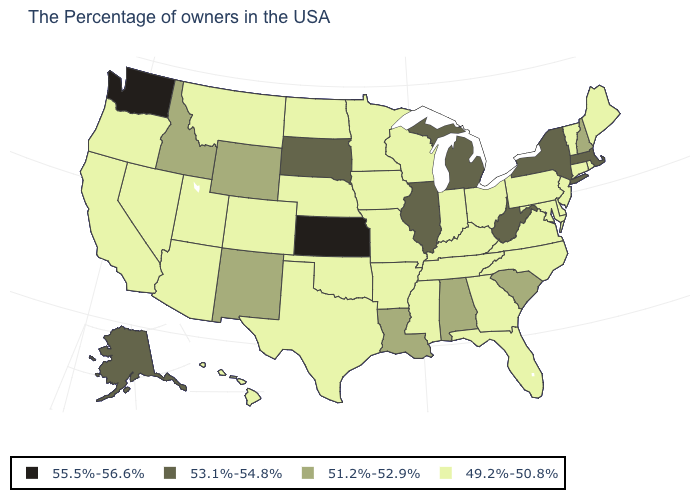Name the states that have a value in the range 55.5%-56.6%?
Give a very brief answer. Kansas, Washington. What is the value of New Hampshire?
Be succinct. 51.2%-52.9%. What is the value of Virginia?
Be succinct. 49.2%-50.8%. What is the value of Kansas?
Concise answer only. 55.5%-56.6%. Does Illinois have the lowest value in the MidWest?
Short answer required. No. Among the states that border Maine , which have the lowest value?
Give a very brief answer. New Hampshire. Is the legend a continuous bar?
Keep it brief. No. Does the map have missing data?
Answer briefly. No. What is the lowest value in the USA?
Be succinct. 49.2%-50.8%. What is the lowest value in the USA?
Keep it brief. 49.2%-50.8%. Which states have the lowest value in the West?
Write a very short answer. Colorado, Utah, Montana, Arizona, Nevada, California, Oregon, Hawaii. Does the map have missing data?
Be succinct. No. Name the states that have a value in the range 53.1%-54.8%?
Be succinct. Massachusetts, New York, West Virginia, Michigan, Illinois, South Dakota, Alaska. Is the legend a continuous bar?
Write a very short answer. No. Does Kansas have the highest value in the USA?
Concise answer only. Yes. 